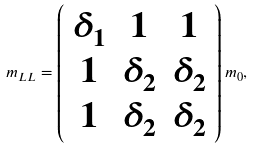<formula> <loc_0><loc_0><loc_500><loc_500>m _ { L L } = \left ( \begin{array} { c c c } \delta _ { 1 } & 1 & 1 \\ 1 & \delta _ { 2 } & \delta _ { 2 } \\ 1 & \delta _ { 2 } & \delta _ { 2 } \end{array} \right ) m _ { 0 } ,</formula> 